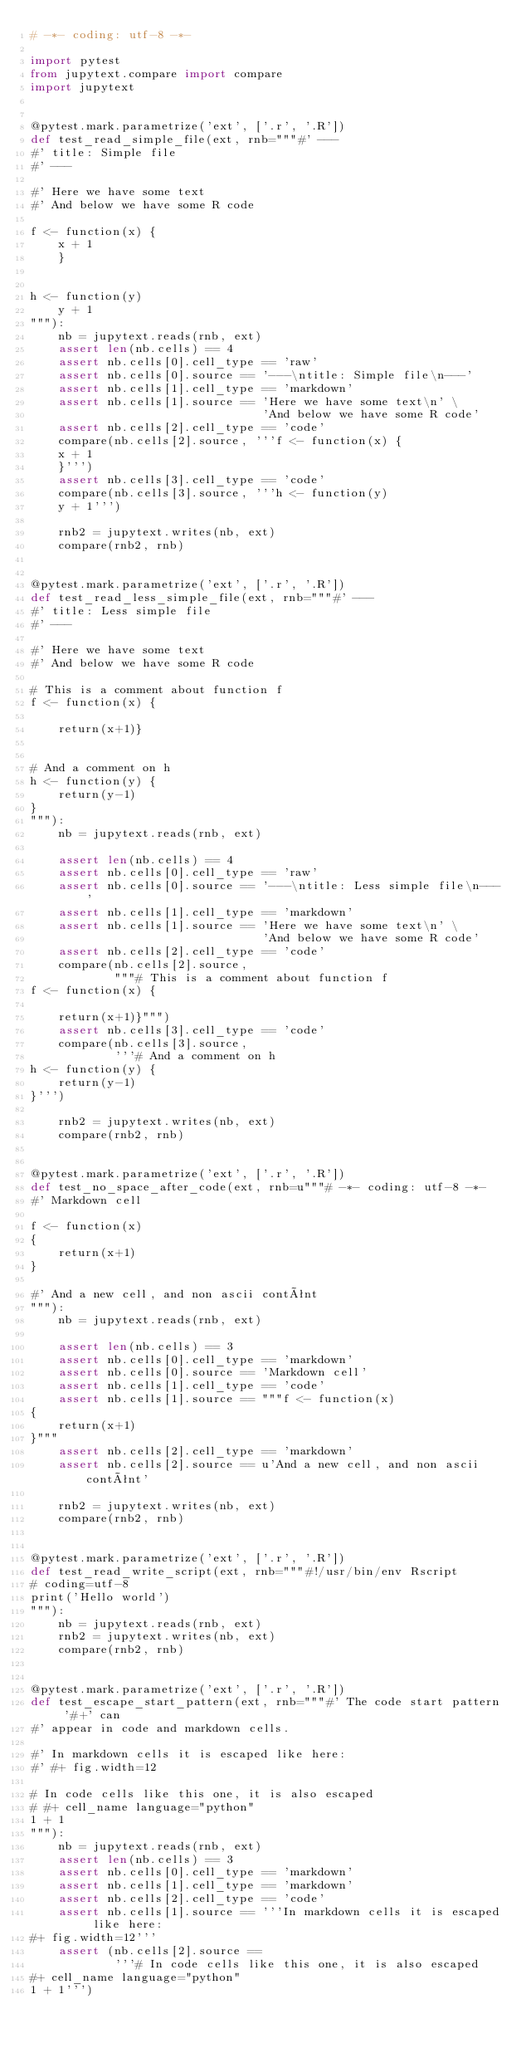Convert code to text. <code><loc_0><loc_0><loc_500><loc_500><_Python_># -*- coding: utf-8 -*-

import pytest
from jupytext.compare import compare
import jupytext


@pytest.mark.parametrize('ext', ['.r', '.R'])
def test_read_simple_file(ext, rnb="""#' ---
#' title: Simple file
#' ---

#' Here we have some text
#' And below we have some R code

f <- function(x) {
    x + 1
    }


h <- function(y)
    y + 1
"""):
    nb = jupytext.reads(rnb, ext)
    assert len(nb.cells) == 4
    assert nb.cells[0].cell_type == 'raw'
    assert nb.cells[0].source == '---\ntitle: Simple file\n---'
    assert nb.cells[1].cell_type == 'markdown'
    assert nb.cells[1].source == 'Here we have some text\n' \
                                 'And below we have some R code'
    assert nb.cells[2].cell_type == 'code'
    compare(nb.cells[2].source, '''f <- function(x) {
    x + 1
    }''')
    assert nb.cells[3].cell_type == 'code'
    compare(nb.cells[3].source, '''h <- function(y)
    y + 1''')

    rnb2 = jupytext.writes(nb, ext)
    compare(rnb2, rnb)


@pytest.mark.parametrize('ext', ['.r', '.R'])
def test_read_less_simple_file(ext, rnb="""#' ---
#' title: Less simple file
#' ---

#' Here we have some text
#' And below we have some R code

# This is a comment about function f
f <- function(x) {

    return(x+1)}


# And a comment on h
h <- function(y) {
    return(y-1)
}
"""):
    nb = jupytext.reads(rnb, ext)

    assert len(nb.cells) == 4
    assert nb.cells[0].cell_type == 'raw'
    assert nb.cells[0].source == '---\ntitle: Less simple file\n---'
    assert nb.cells[1].cell_type == 'markdown'
    assert nb.cells[1].source == 'Here we have some text\n' \
                                 'And below we have some R code'
    assert nb.cells[2].cell_type == 'code'
    compare(nb.cells[2].source,
            """# This is a comment about function f
f <- function(x) {

    return(x+1)}""")
    assert nb.cells[3].cell_type == 'code'
    compare(nb.cells[3].source,
            '''# And a comment on h
h <- function(y) {
    return(y-1)
}''')

    rnb2 = jupytext.writes(nb, ext)
    compare(rnb2, rnb)


@pytest.mark.parametrize('ext', ['.r', '.R'])
def test_no_space_after_code(ext, rnb=u"""# -*- coding: utf-8 -*-
#' Markdown cell

f <- function(x)
{
    return(x+1)
}

#' And a new cell, and non ascii contênt
"""):
    nb = jupytext.reads(rnb, ext)

    assert len(nb.cells) == 3
    assert nb.cells[0].cell_type == 'markdown'
    assert nb.cells[0].source == 'Markdown cell'
    assert nb.cells[1].cell_type == 'code'
    assert nb.cells[1].source == """f <- function(x)
{
    return(x+1)
}"""
    assert nb.cells[2].cell_type == 'markdown'
    assert nb.cells[2].source == u'And a new cell, and non ascii contênt'

    rnb2 = jupytext.writes(nb, ext)
    compare(rnb2, rnb)


@pytest.mark.parametrize('ext', ['.r', '.R'])
def test_read_write_script(ext, rnb="""#!/usr/bin/env Rscript
# coding=utf-8
print('Hello world')
"""):
    nb = jupytext.reads(rnb, ext)
    rnb2 = jupytext.writes(nb, ext)
    compare(rnb2, rnb)


@pytest.mark.parametrize('ext', ['.r', '.R'])
def test_escape_start_pattern(ext, rnb="""#' The code start pattern '#+' can
#' appear in code and markdown cells.

#' In markdown cells it is escaped like here:
#' #+ fig.width=12

# In code cells like this one, it is also escaped
# #+ cell_name language="python"
1 + 1
"""):
    nb = jupytext.reads(rnb, ext)
    assert len(nb.cells) == 3
    assert nb.cells[0].cell_type == 'markdown'
    assert nb.cells[1].cell_type == 'markdown'
    assert nb.cells[2].cell_type == 'code'
    assert nb.cells[1].source == '''In markdown cells it is escaped like here:
#+ fig.width=12'''
    assert (nb.cells[2].source ==
            '''# In code cells like this one, it is also escaped
#+ cell_name language="python"
1 + 1''')</code> 